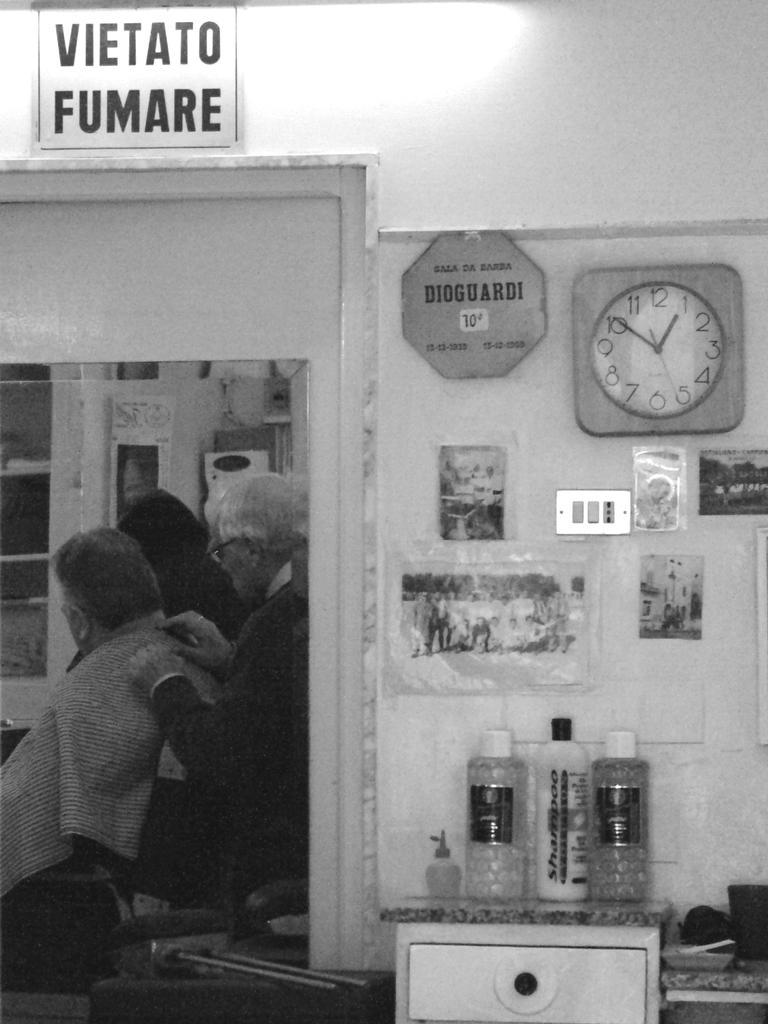Please provide a concise description of this image. This is the black and white image where we can see photo frames, socket and photo frames on the wall. Here we can see bottles kept on the wooden drawer and a mirror through which we can see this person is sitting on the chair and this person is standing. 